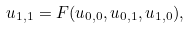<formula> <loc_0><loc_0><loc_500><loc_500>u _ { 1 , 1 } = F ( u _ { 0 , 0 } , u _ { 0 , 1 } , u _ { 1 , 0 } ) ,</formula> 